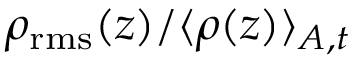<formula> <loc_0><loc_0><loc_500><loc_500>\rho _ { r m s } ( z ) / \langle \rho ( z ) \rangle _ { A , t }</formula> 